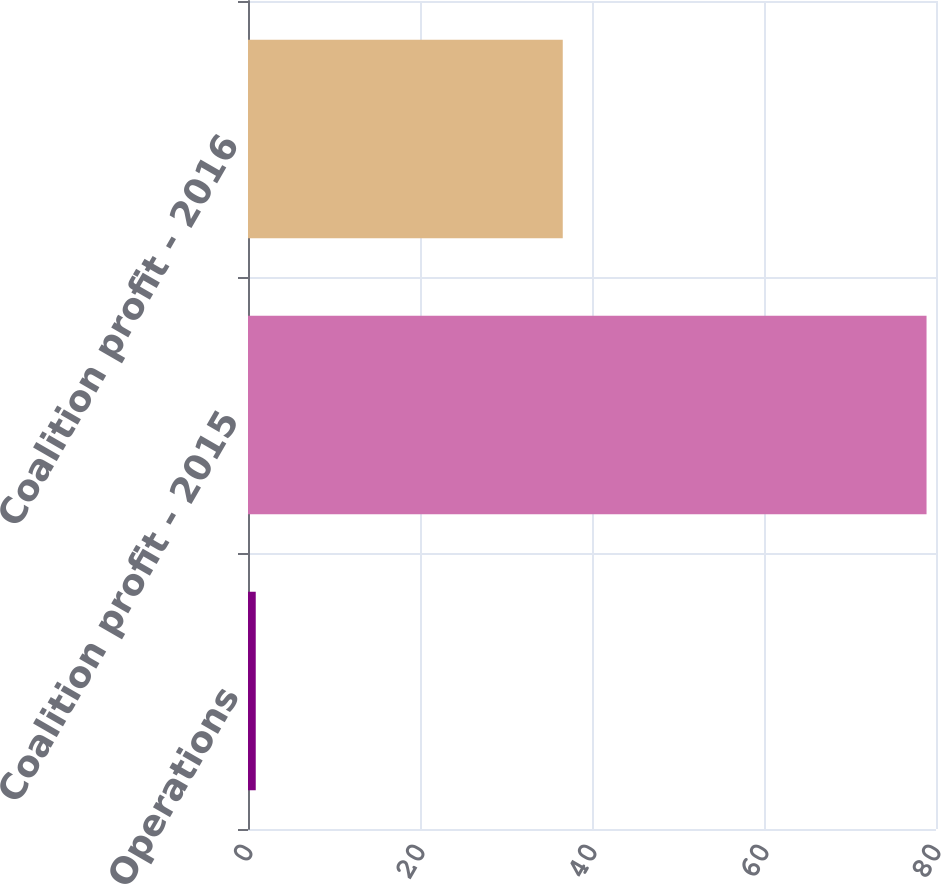Convert chart to OTSL. <chart><loc_0><loc_0><loc_500><loc_500><bar_chart><fcel>Operations<fcel>Coalition profit - 2015<fcel>Coalition profit - 2016<nl><fcel>0.9<fcel>78.9<fcel>36.6<nl></chart> 